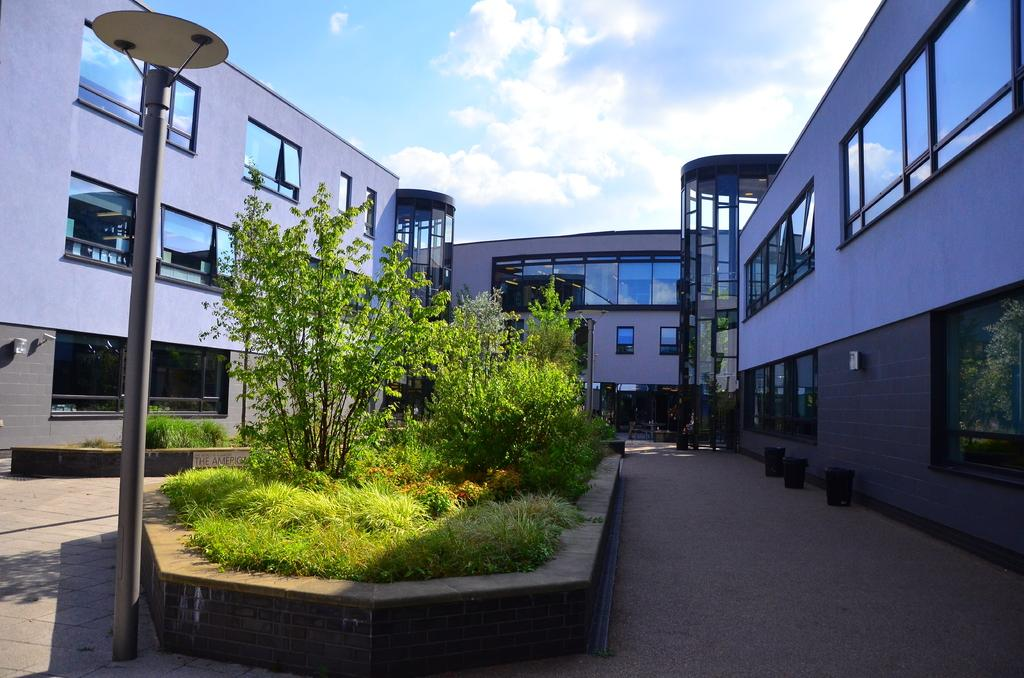What type of structure is visible in the image? There is a building in the image. What feature can be seen on the building? The building has windows. What is located in the middle of the image? There are plants in the middle of the image. What is at the bottom of the image? There is a road at the bottom of the image. What is the income of the bird flying over the building in the image? There is no bird present in the image, so it is not possible to determine its income. 